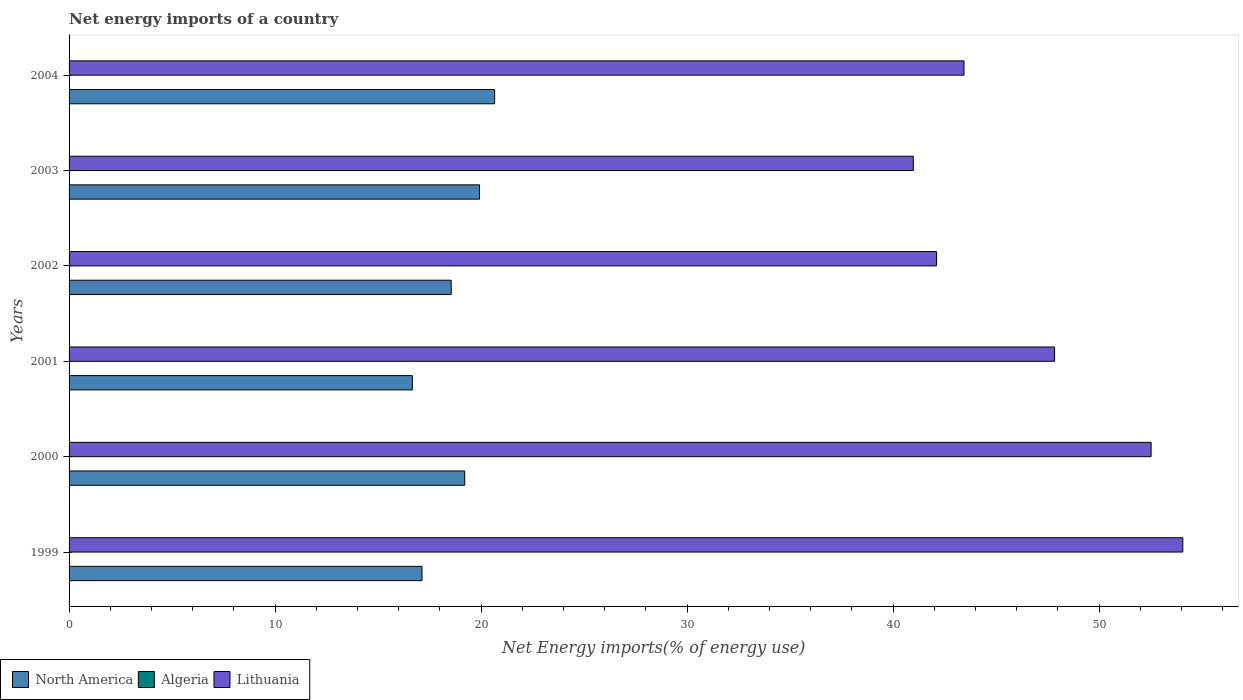What is the label of the 5th group of bars from the top?
Your answer should be compact. 2000. Across all years, what is the maximum net energy imports in North America?
Ensure brevity in your answer.  20.66. Across all years, what is the minimum net energy imports in Lithuania?
Give a very brief answer. 40.98. What is the total net energy imports in North America in the graph?
Ensure brevity in your answer.  112.13. What is the difference between the net energy imports in North America in 2000 and that in 2001?
Give a very brief answer. 2.54. What is the difference between the net energy imports in Algeria in 2004 and the net energy imports in Lithuania in 2002?
Ensure brevity in your answer.  -42.11. What is the average net energy imports in Algeria per year?
Provide a succinct answer. 0. In the year 2003, what is the difference between the net energy imports in North America and net energy imports in Lithuania?
Your response must be concise. -21.06. What is the ratio of the net energy imports in North America in 2001 to that in 2002?
Make the answer very short. 0.9. Is the difference between the net energy imports in North America in 1999 and 2002 greater than the difference between the net energy imports in Lithuania in 1999 and 2002?
Offer a very short reply. No. What is the difference between the highest and the second highest net energy imports in North America?
Provide a short and direct response. 0.73. What is the difference between the highest and the lowest net energy imports in Lithuania?
Your response must be concise. 13.08. Does the graph contain any zero values?
Ensure brevity in your answer.  Yes. How are the legend labels stacked?
Your answer should be compact. Horizontal. What is the title of the graph?
Provide a short and direct response. Net energy imports of a country. What is the label or title of the X-axis?
Give a very brief answer. Net Energy imports(% of energy use). What is the Net Energy imports(% of energy use) in North America in 1999?
Your answer should be compact. 17.13. What is the Net Energy imports(% of energy use) of Algeria in 1999?
Give a very brief answer. 0. What is the Net Energy imports(% of energy use) in Lithuania in 1999?
Your answer should be compact. 54.06. What is the Net Energy imports(% of energy use) in North America in 2000?
Keep it short and to the point. 19.2. What is the Net Energy imports(% of energy use) in Algeria in 2000?
Provide a succinct answer. 0. What is the Net Energy imports(% of energy use) of Lithuania in 2000?
Offer a very short reply. 52.52. What is the Net Energy imports(% of energy use) in North America in 2001?
Keep it short and to the point. 16.66. What is the Net Energy imports(% of energy use) in Lithuania in 2001?
Provide a short and direct response. 47.84. What is the Net Energy imports(% of energy use) of North America in 2002?
Your response must be concise. 18.55. What is the Net Energy imports(% of energy use) of Algeria in 2002?
Offer a very short reply. 0. What is the Net Energy imports(% of energy use) of Lithuania in 2002?
Offer a terse response. 42.11. What is the Net Energy imports(% of energy use) in North America in 2003?
Offer a terse response. 19.92. What is the Net Energy imports(% of energy use) of Lithuania in 2003?
Offer a very short reply. 40.98. What is the Net Energy imports(% of energy use) in North America in 2004?
Your answer should be compact. 20.66. What is the Net Energy imports(% of energy use) of Algeria in 2004?
Provide a succinct answer. 0. What is the Net Energy imports(% of energy use) of Lithuania in 2004?
Offer a terse response. 43.44. Across all years, what is the maximum Net Energy imports(% of energy use) of North America?
Your answer should be compact. 20.66. Across all years, what is the maximum Net Energy imports(% of energy use) in Lithuania?
Your answer should be compact. 54.06. Across all years, what is the minimum Net Energy imports(% of energy use) of North America?
Offer a very short reply. 16.66. Across all years, what is the minimum Net Energy imports(% of energy use) in Lithuania?
Your answer should be compact. 40.98. What is the total Net Energy imports(% of energy use) in North America in the graph?
Your response must be concise. 112.13. What is the total Net Energy imports(% of energy use) of Algeria in the graph?
Make the answer very short. 0. What is the total Net Energy imports(% of energy use) in Lithuania in the graph?
Ensure brevity in your answer.  280.94. What is the difference between the Net Energy imports(% of energy use) of North America in 1999 and that in 2000?
Provide a short and direct response. -2.07. What is the difference between the Net Energy imports(% of energy use) of Lithuania in 1999 and that in 2000?
Your answer should be compact. 1.54. What is the difference between the Net Energy imports(% of energy use) in North America in 1999 and that in 2001?
Your answer should be compact. 0.47. What is the difference between the Net Energy imports(% of energy use) of Lithuania in 1999 and that in 2001?
Make the answer very short. 6.23. What is the difference between the Net Energy imports(% of energy use) of North America in 1999 and that in 2002?
Give a very brief answer. -1.42. What is the difference between the Net Energy imports(% of energy use) in Lithuania in 1999 and that in 2002?
Your response must be concise. 11.95. What is the difference between the Net Energy imports(% of energy use) in North America in 1999 and that in 2003?
Keep it short and to the point. -2.79. What is the difference between the Net Energy imports(% of energy use) of Lithuania in 1999 and that in 2003?
Provide a short and direct response. 13.08. What is the difference between the Net Energy imports(% of energy use) of North America in 1999 and that in 2004?
Provide a short and direct response. -3.52. What is the difference between the Net Energy imports(% of energy use) in Lithuania in 1999 and that in 2004?
Offer a very short reply. 10.62. What is the difference between the Net Energy imports(% of energy use) in North America in 2000 and that in 2001?
Offer a terse response. 2.54. What is the difference between the Net Energy imports(% of energy use) in Lithuania in 2000 and that in 2001?
Keep it short and to the point. 4.69. What is the difference between the Net Energy imports(% of energy use) of North America in 2000 and that in 2002?
Your answer should be compact. 0.66. What is the difference between the Net Energy imports(% of energy use) of Lithuania in 2000 and that in 2002?
Your answer should be very brief. 10.41. What is the difference between the Net Energy imports(% of energy use) of North America in 2000 and that in 2003?
Offer a terse response. -0.72. What is the difference between the Net Energy imports(% of energy use) of Lithuania in 2000 and that in 2003?
Offer a very short reply. 11.54. What is the difference between the Net Energy imports(% of energy use) in North America in 2000 and that in 2004?
Make the answer very short. -1.45. What is the difference between the Net Energy imports(% of energy use) in Lithuania in 2000 and that in 2004?
Give a very brief answer. 9.08. What is the difference between the Net Energy imports(% of energy use) of North America in 2001 and that in 2002?
Provide a succinct answer. -1.89. What is the difference between the Net Energy imports(% of energy use) in Lithuania in 2001 and that in 2002?
Your answer should be compact. 5.73. What is the difference between the Net Energy imports(% of energy use) in North America in 2001 and that in 2003?
Provide a short and direct response. -3.26. What is the difference between the Net Energy imports(% of energy use) in Lithuania in 2001 and that in 2003?
Your response must be concise. 6.86. What is the difference between the Net Energy imports(% of energy use) in North America in 2001 and that in 2004?
Your answer should be compact. -4. What is the difference between the Net Energy imports(% of energy use) in Lithuania in 2001 and that in 2004?
Keep it short and to the point. 4.4. What is the difference between the Net Energy imports(% of energy use) in North America in 2002 and that in 2003?
Give a very brief answer. -1.38. What is the difference between the Net Energy imports(% of energy use) in Lithuania in 2002 and that in 2003?
Ensure brevity in your answer.  1.13. What is the difference between the Net Energy imports(% of energy use) of North America in 2002 and that in 2004?
Offer a terse response. -2.11. What is the difference between the Net Energy imports(% of energy use) in Lithuania in 2002 and that in 2004?
Make the answer very short. -1.33. What is the difference between the Net Energy imports(% of energy use) in North America in 2003 and that in 2004?
Make the answer very short. -0.73. What is the difference between the Net Energy imports(% of energy use) in Lithuania in 2003 and that in 2004?
Your answer should be very brief. -2.46. What is the difference between the Net Energy imports(% of energy use) of North America in 1999 and the Net Energy imports(% of energy use) of Lithuania in 2000?
Make the answer very short. -35.39. What is the difference between the Net Energy imports(% of energy use) in North America in 1999 and the Net Energy imports(% of energy use) in Lithuania in 2001?
Offer a terse response. -30.7. What is the difference between the Net Energy imports(% of energy use) of North America in 1999 and the Net Energy imports(% of energy use) of Lithuania in 2002?
Your answer should be compact. -24.98. What is the difference between the Net Energy imports(% of energy use) in North America in 1999 and the Net Energy imports(% of energy use) in Lithuania in 2003?
Provide a short and direct response. -23.85. What is the difference between the Net Energy imports(% of energy use) of North America in 1999 and the Net Energy imports(% of energy use) of Lithuania in 2004?
Offer a terse response. -26.31. What is the difference between the Net Energy imports(% of energy use) in North America in 2000 and the Net Energy imports(% of energy use) in Lithuania in 2001?
Keep it short and to the point. -28.63. What is the difference between the Net Energy imports(% of energy use) of North America in 2000 and the Net Energy imports(% of energy use) of Lithuania in 2002?
Provide a short and direct response. -22.9. What is the difference between the Net Energy imports(% of energy use) in North America in 2000 and the Net Energy imports(% of energy use) in Lithuania in 2003?
Keep it short and to the point. -21.78. What is the difference between the Net Energy imports(% of energy use) of North America in 2000 and the Net Energy imports(% of energy use) of Lithuania in 2004?
Give a very brief answer. -24.23. What is the difference between the Net Energy imports(% of energy use) in North America in 2001 and the Net Energy imports(% of energy use) in Lithuania in 2002?
Offer a very short reply. -25.45. What is the difference between the Net Energy imports(% of energy use) in North America in 2001 and the Net Energy imports(% of energy use) in Lithuania in 2003?
Give a very brief answer. -24.32. What is the difference between the Net Energy imports(% of energy use) of North America in 2001 and the Net Energy imports(% of energy use) of Lithuania in 2004?
Give a very brief answer. -26.78. What is the difference between the Net Energy imports(% of energy use) in North America in 2002 and the Net Energy imports(% of energy use) in Lithuania in 2003?
Provide a succinct answer. -22.43. What is the difference between the Net Energy imports(% of energy use) in North America in 2002 and the Net Energy imports(% of energy use) in Lithuania in 2004?
Provide a short and direct response. -24.89. What is the difference between the Net Energy imports(% of energy use) of North America in 2003 and the Net Energy imports(% of energy use) of Lithuania in 2004?
Offer a very short reply. -23.51. What is the average Net Energy imports(% of energy use) of North America per year?
Provide a succinct answer. 18.69. What is the average Net Energy imports(% of energy use) of Lithuania per year?
Your answer should be very brief. 46.82. In the year 1999, what is the difference between the Net Energy imports(% of energy use) of North America and Net Energy imports(% of energy use) of Lithuania?
Ensure brevity in your answer.  -36.93. In the year 2000, what is the difference between the Net Energy imports(% of energy use) of North America and Net Energy imports(% of energy use) of Lithuania?
Your answer should be very brief. -33.32. In the year 2001, what is the difference between the Net Energy imports(% of energy use) in North America and Net Energy imports(% of energy use) in Lithuania?
Your response must be concise. -31.17. In the year 2002, what is the difference between the Net Energy imports(% of energy use) of North America and Net Energy imports(% of energy use) of Lithuania?
Offer a very short reply. -23.56. In the year 2003, what is the difference between the Net Energy imports(% of energy use) of North America and Net Energy imports(% of energy use) of Lithuania?
Offer a terse response. -21.06. In the year 2004, what is the difference between the Net Energy imports(% of energy use) of North America and Net Energy imports(% of energy use) of Lithuania?
Keep it short and to the point. -22.78. What is the ratio of the Net Energy imports(% of energy use) of North America in 1999 to that in 2000?
Provide a succinct answer. 0.89. What is the ratio of the Net Energy imports(% of energy use) of Lithuania in 1999 to that in 2000?
Ensure brevity in your answer.  1.03. What is the ratio of the Net Energy imports(% of energy use) of North America in 1999 to that in 2001?
Your response must be concise. 1.03. What is the ratio of the Net Energy imports(% of energy use) in Lithuania in 1999 to that in 2001?
Ensure brevity in your answer.  1.13. What is the ratio of the Net Energy imports(% of energy use) of North America in 1999 to that in 2002?
Your response must be concise. 0.92. What is the ratio of the Net Energy imports(% of energy use) in Lithuania in 1999 to that in 2002?
Your response must be concise. 1.28. What is the ratio of the Net Energy imports(% of energy use) of North America in 1999 to that in 2003?
Ensure brevity in your answer.  0.86. What is the ratio of the Net Energy imports(% of energy use) in Lithuania in 1999 to that in 2003?
Provide a short and direct response. 1.32. What is the ratio of the Net Energy imports(% of energy use) of North America in 1999 to that in 2004?
Your response must be concise. 0.83. What is the ratio of the Net Energy imports(% of energy use) of Lithuania in 1999 to that in 2004?
Make the answer very short. 1.24. What is the ratio of the Net Energy imports(% of energy use) in North America in 2000 to that in 2001?
Keep it short and to the point. 1.15. What is the ratio of the Net Energy imports(% of energy use) in Lithuania in 2000 to that in 2001?
Your answer should be very brief. 1.1. What is the ratio of the Net Energy imports(% of energy use) of North America in 2000 to that in 2002?
Make the answer very short. 1.04. What is the ratio of the Net Energy imports(% of energy use) in Lithuania in 2000 to that in 2002?
Your answer should be very brief. 1.25. What is the ratio of the Net Energy imports(% of energy use) of North America in 2000 to that in 2003?
Keep it short and to the point. 0.96. What is the ratio of the Net Energy imports(% of energy use) in Lithuania in 2000 to that in 2003?
Offer a very short reply. 1.28. What is the ratio of the Net Energy imports(% of energy use) of North America in 2000 to that in 2004?
Offer a terse response. 0.93. What is the ratio of the Net Energy imports(% of energy use) in Lithuania in 2000 to that in 2004?
Make the answer very short. 1.21. What is the ratio of the Net Energy imports(% of energy use) in North America in 2001 to that in 2002?
Provide a succinct answer. 0.9. What is the ratio of the Net Energy imports(% of energy use) in Lithuania in 2001 to that in 2002?
Provide a short and direct response. 1.14. What is the ratio of the Net Energy imports(% of energy use) in North America in 2001 to that in 2003?
Ensure brevity in your answer.  0.84. What is the ratio of the Net Energy imports(% of energy use) of Lithuania in 2001 to that in 2003?
Offer a terse response. 1.17. What is the ratio of the Net Energy imports(% of energy use) in North America in 2001 to that in 2004?
Offer a very short reply. 0.81. What is the ratio of the Net Energy imports(% of energy use) in Lithuania in 2001 to that in 2004?
Provide a short and direct response. 1.1. What is the ratio of the Net Energy imports(% of energy use) of North America in 2002 to that in 2003?
Ensure brevity in your answer.  0.93. What is the ratio of the Net Energy imports(% of energy use) of Lithuania in 2002 to that in 2003?
Offer a very short reply. 1.03. What is the ratio of the Net Energy imports(% of energy use) of North America in 2002 to that in 2004?
Provide a short and direct response. 0.9. What is the ratio of the Net Energy imports(% of energy use) of Lithuania in 2002 to that in 2004?
Provide a succinct answer. 0.97. What is the ratio of the Net Energy imports(% of energy use) in North America in 2003 to that in 2004?
Offer a terse response. 0.96. What is the ratio of the Net Energy imports(% of energy use) of Lithuania in 2003 to that in 2004?
Give a very brief answer. 0.94. What is the difference between the highest and the second highest Net Energy imports(% of energy use) of North America?
Your response must be concise. 0.73. What is the difference between the highest and the second highest Net Energy imports(% of energy use) in Lithuania?
Provide a short and direct response. 1.54. What is the difference between the highest and the lowest Net Energy imports(% of energy use) of North America?
Give a very brief answer. 4. What is the difference between the highest and the lowest Net Energy imports(% of energy use) in Lithuania?
Ensure brevity in your answer.  13.08. 